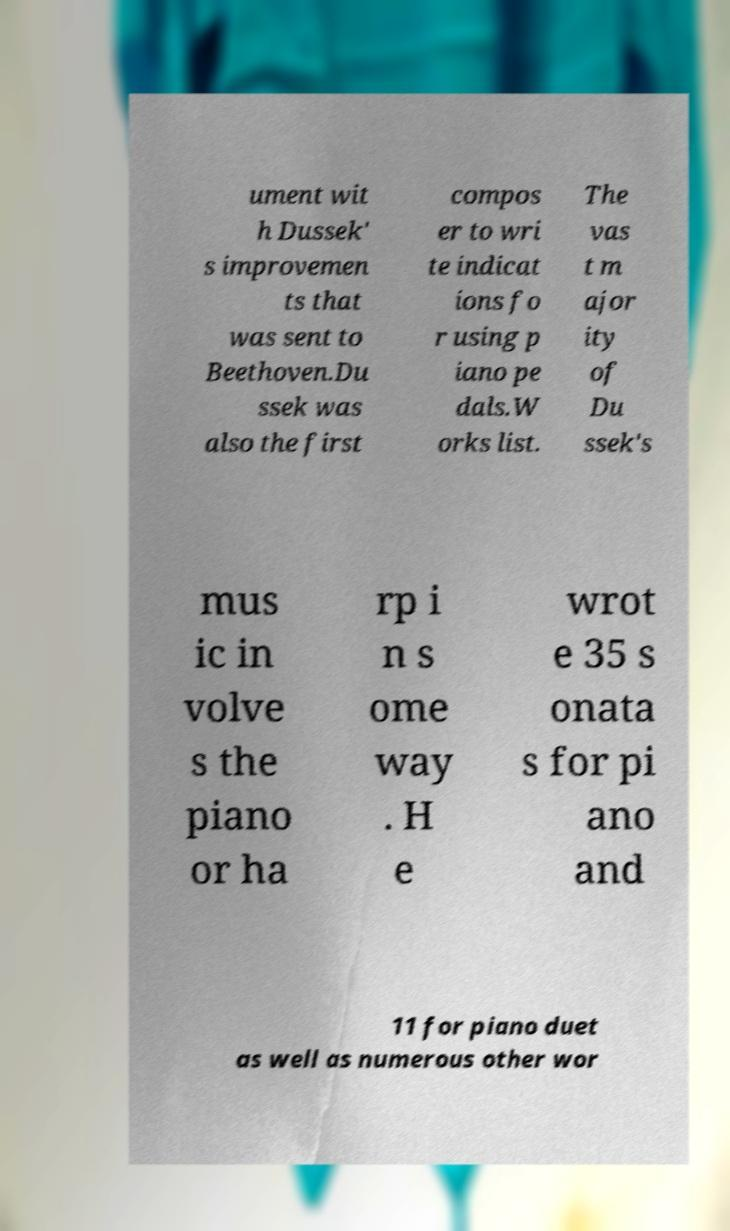What messages or text are displayed in this image? I need them in a readable, typed format. ument wit h Dussek' s improvemen ts that was sent to Beethoven.Du ssek was also the first compos er to wri te indicat ions fo r using p iano pe dals.W orks list. The vas t m ajor ity of Du ssek's mus ic in volve s the piano or ha rp i n s ome way . H e wrot e 35 s onata s for pi ano and 11 for piano duet as well as numerous other wor 